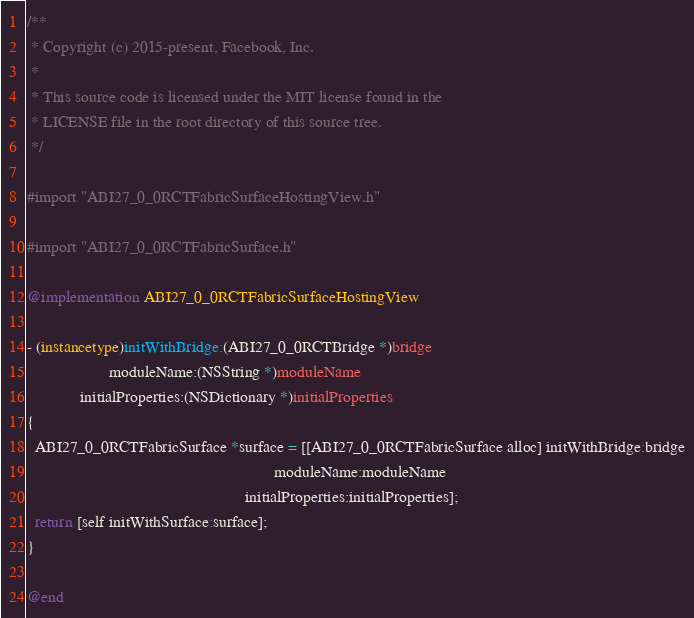<code> <loc_0><loc_0><loc_500><loc_500><_ObjectiveC_>/**
 * Copyright (c) 2015-present, Facebook, Inc.
 *
 * This source code is licensed under the MIT license found in the
 * LICENSE file in the root directory of this source tree.
 */

#import "ABI27_0_0RCTFabricSurfaceHostingView.h"

#import "ABI27_0_0RCTFabricSurface.h"

@implementation ABI27_0_0RCTFabricSurfaceHostingView

- (instancetype)initWithBridge:(ABI27_0_0RCTBridge *)bridge
                    moduleName:(NSString *)moduleName
             initialProperties:(NSDictionary *)initialProperties
{
  ABI27_0_0RCTFabricSurface *surface = [[ABI27_0_0RCTFabricSurface alloc] initWithBridge:bridge
                                                            moduleName:moduleName
                                                     initialProperties:initialProperties];
  return [self initWithSurface:surface];
}

@end

</code> 